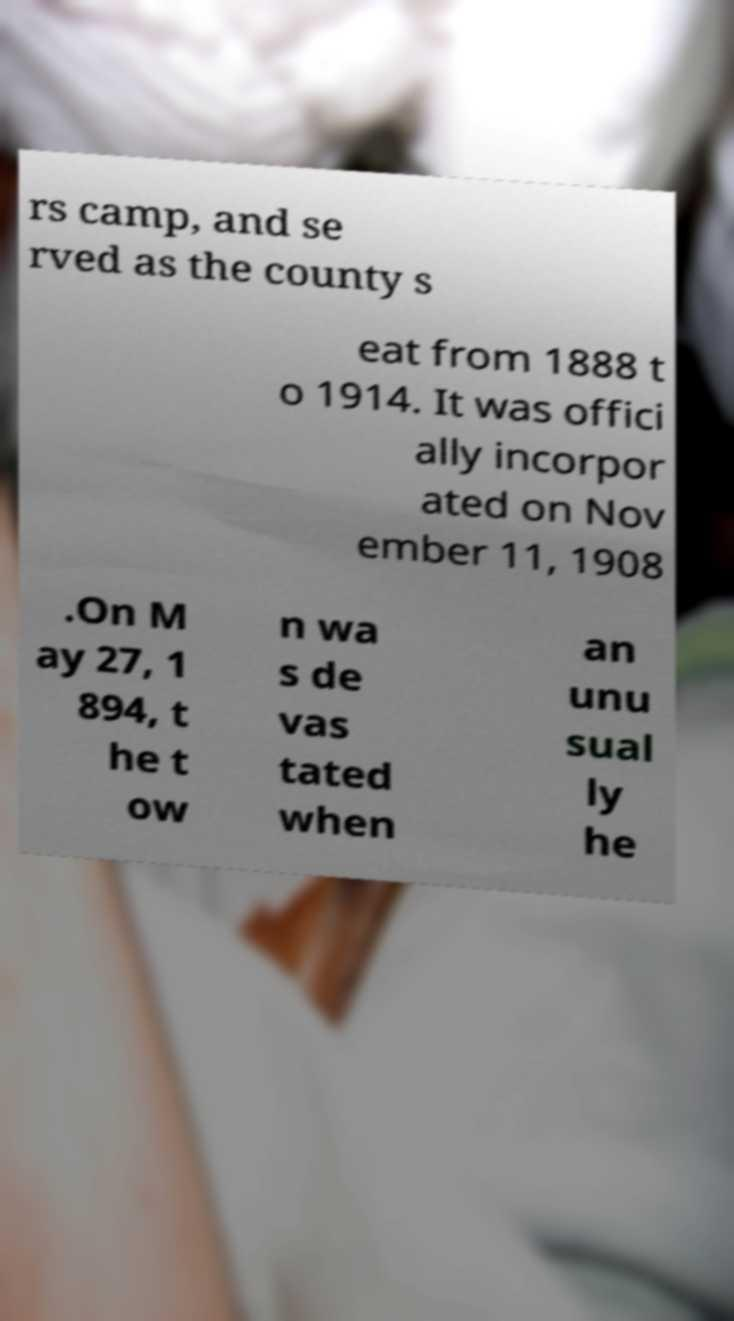Can you read and provide the text displayed in the image?This photo seems to have some interesting text. Can you extract and type it out for me? rs camp, and se rved as the county s eat from 1888 t o 1914. It was offici ally incorpor ated on Nov ember 11, 1908 .On M ay 27, 1 894, t he t ow n wa s de vas tated when an unu sual ly he 